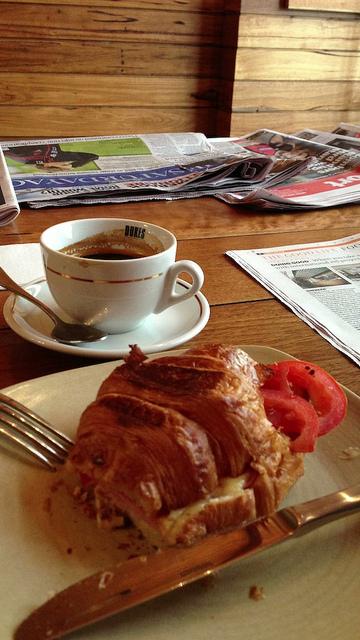Is this vegetarian food?
Answer briefly. No. What utensils can be seen in this picture?
Answer briefly. Fork, knife, and spoon. Does that look like a cold beverage?
Write a very short answer. No. What is the table made out of?
Short answer required. Wood. 